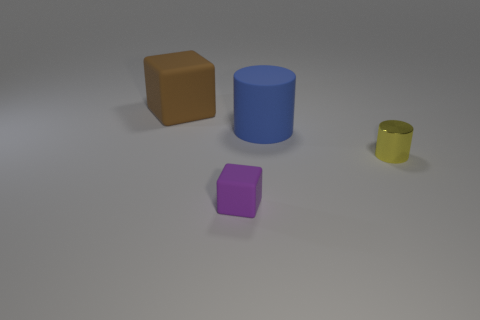Is there anything else that has the same shape as the purple object? Aside from the purple object, which is a cube, there appears to be no other objects in the image with an identical shape. The closest is the brown object; it's also a cube but larger in size. 